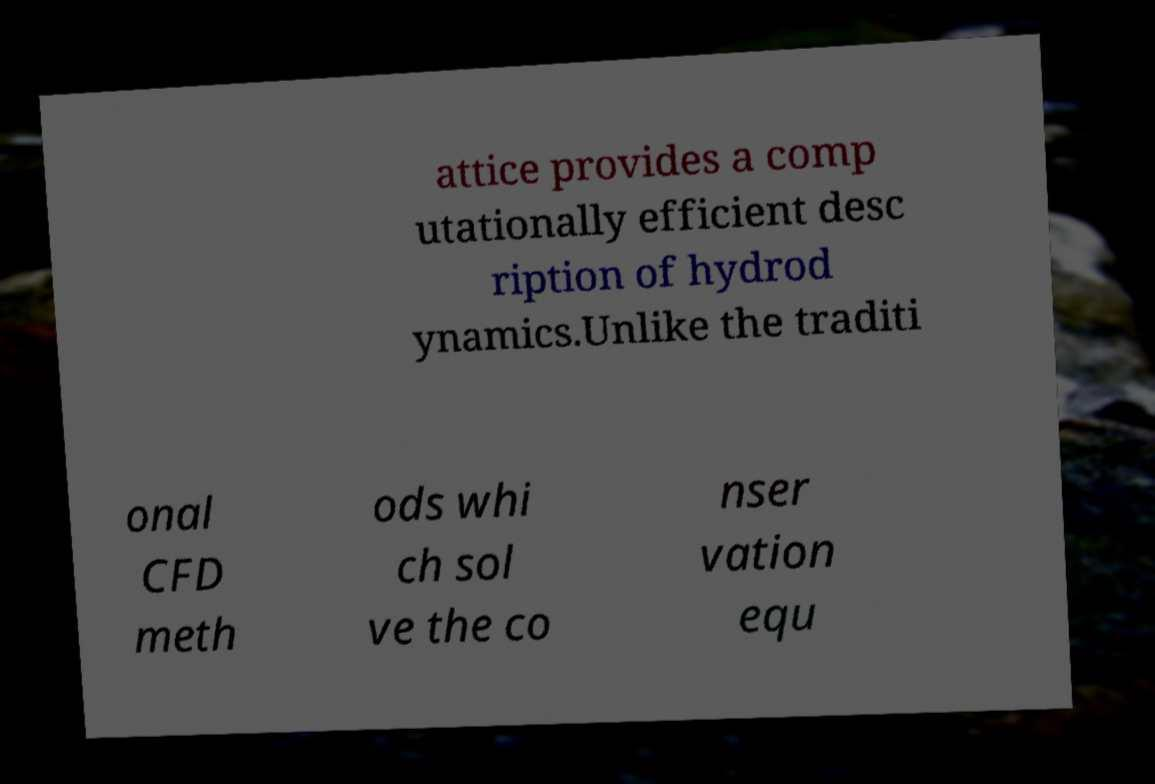Can you read and provide the text displayed in the image?This photo seems to have some interesting text. Can you extract and type it out for me? attice provides a comp utationally efficient desc ription of hydrod ynamics.Unlike the traditi onal CFD meth ods whi ch sol ve the co nser vation equ 